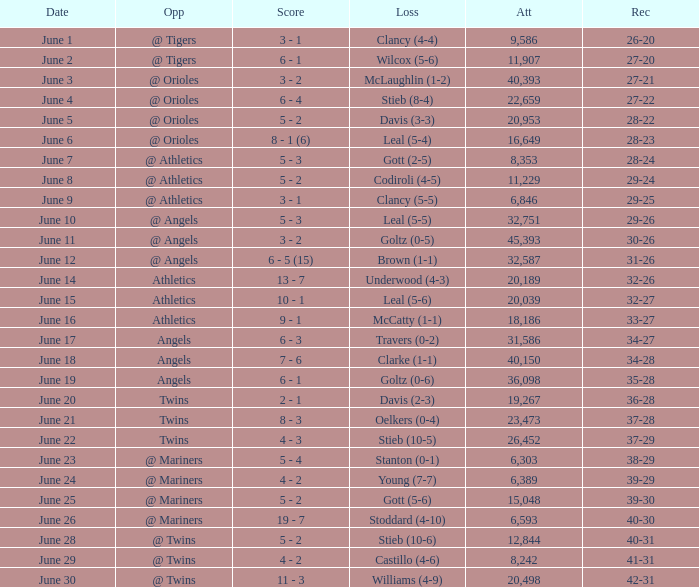What was the record where the opponent was @ Orioles and the loss was to Leal (5-4)? 28-23. 